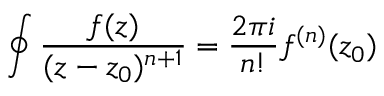<formula> <loc_0><loc_0><loc_500><loc_500>\oint \frac { f ( z ) } { ( z - z _ { 0 } ) ^ { n + 1 } } = \frac { 2 \pi i } { n ! } f ^ { ( n ) } ( z _ { 0 } )</formula> 